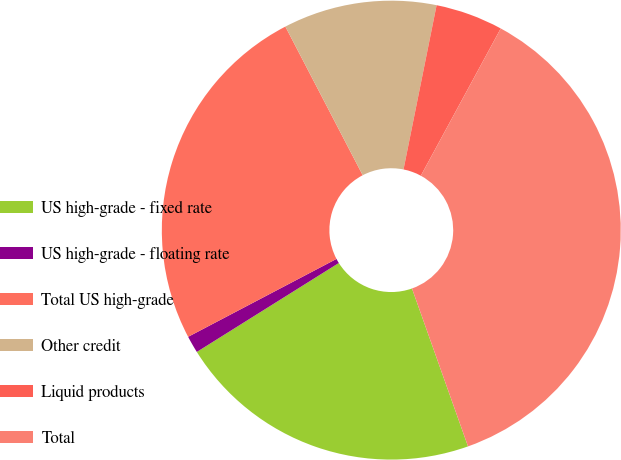Convert chart to OTSL. <chart><loc_0><loc_0><loc_500><loc_500><pie_chart><fcel>US high-grade - fixed rate<fcel>US high-grade - floating rate<fcel>Total US high-grade<fcel>Other credit<fcel>Liquid products<fcel>Total<nl><fcel>21.52%<fcel>1.21%<fcel>25.06%<fcel>10.8%<fcel>4.75%<fcel>36.66%<nl></chart> 